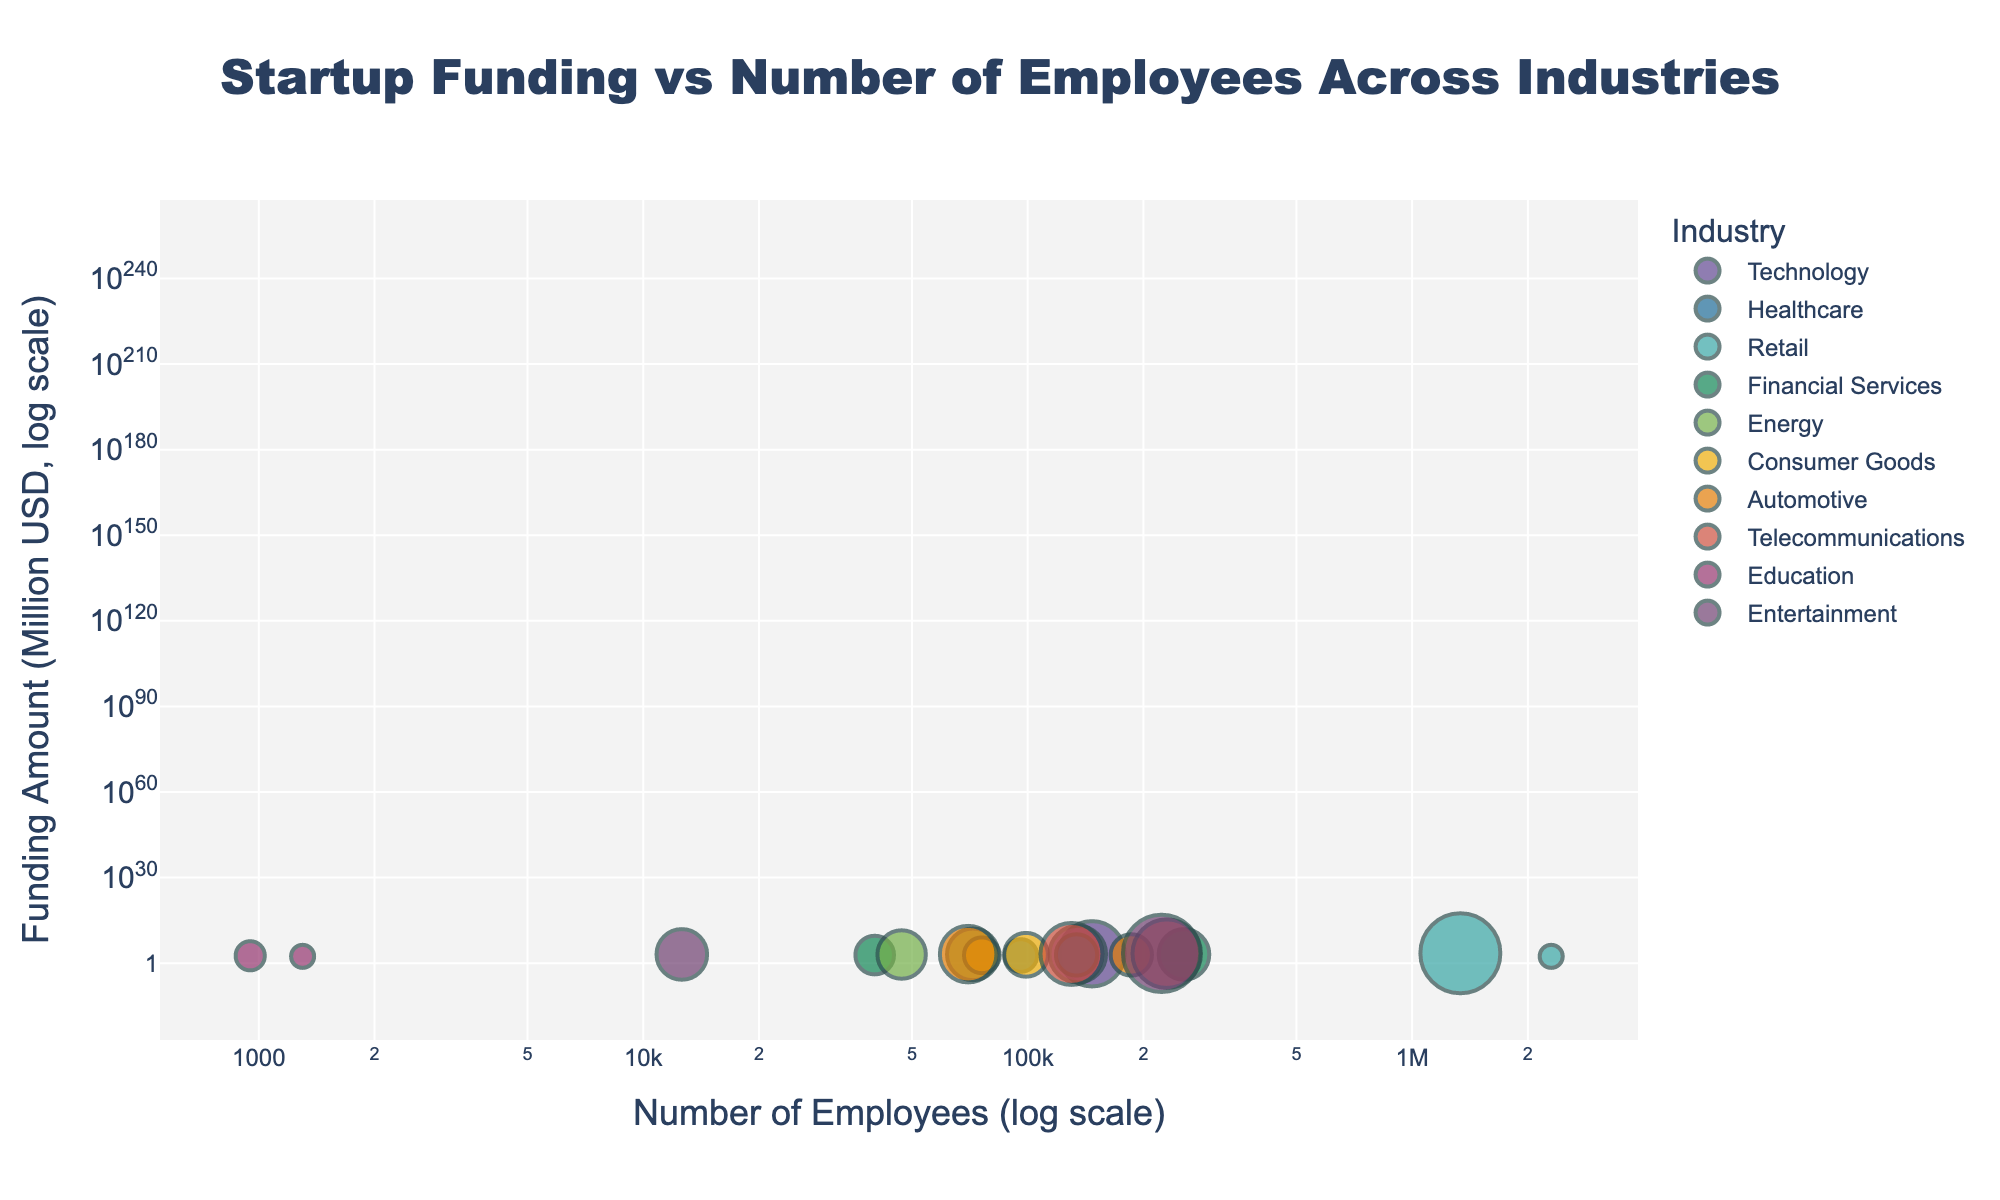Which company has the highest funding amount? Looking at the y-axis and identifying the highest data point, we can see that Amazon has the highest funding amount with $3000 million USD.
Answer: Amazon Which industry has the company with the most employees? Identify the data point further to the right on the x-axis. Walmart in the Retail industry has the most employees with 2,300,000.
Answer: Retail (Walmart) What is the average number of employees for companies in the Healthcare industry? Identify the data points in the Healthcare industry, which are Johnson & Johnson (134,000) and Pfizer (96,000). The average is (134000 + 96000) / 2 = 115000.
Answer: 115,000 Which company in the Automotive industry has received more funding? Compare the funding amounts (y-axis) of Tesla and Ford. Tesla has $1500 million USD, whereas Ford has $800 million USD. Tesla received more funding.
Answer: Tesla Are educational companies generally smaller in terms of employee size than healthcare companies? Compare the number of employees in the Education industry (Coursera - 950, Udemy - 1300) to those in the Healthcare industry (Johnson & Johnson - 134000, Pfizer - 96000). The education companies have significantly fewer employees.
Answer: Yes Which industry generally has larger companies in terms of employees, Entertainment or Consumer Goods? Compare the number of employees of companies in the Entertainment industry (Netflix - 12600, Disney - 223000) with those in the Consumer Goods industry (Procter & Gamble - 99000, Nike - 76000). Overall, the Entertainment industry tends to have larger companies.
Answer: Entertainment What is the total amount of funding received by companies in the Financial Services industry? Add the funding amounts for Goldman Sachs ($700 million USD) and JP Morgan ($1200 million USD). The total is 700 + 1200 = 1900.
Answer: $1900 million USD Which company has more employees, Exxon Mobil or Chevron? Compare the number of employees from the Energy industry data points. Exxon Mobil has 72000, and Chevron has 47000. Exxon Mobil has more employees.
Answer: Exxon Mobil Does a higher number of employees correlate with higher funding within the dataset? Review the scatter plot trend. There is no clear correlation, as companies with high employee numbers (e.g., Walmart) do not necessarily have the highest funding.
Answer: No What is the range of funding amounts in the Technology industry? Identify the funding amounts of Apple ($2000 million USD) and Google ($1500 million USD). The range is 2000 - 1500 = 500.
Answer: $500 million USD 